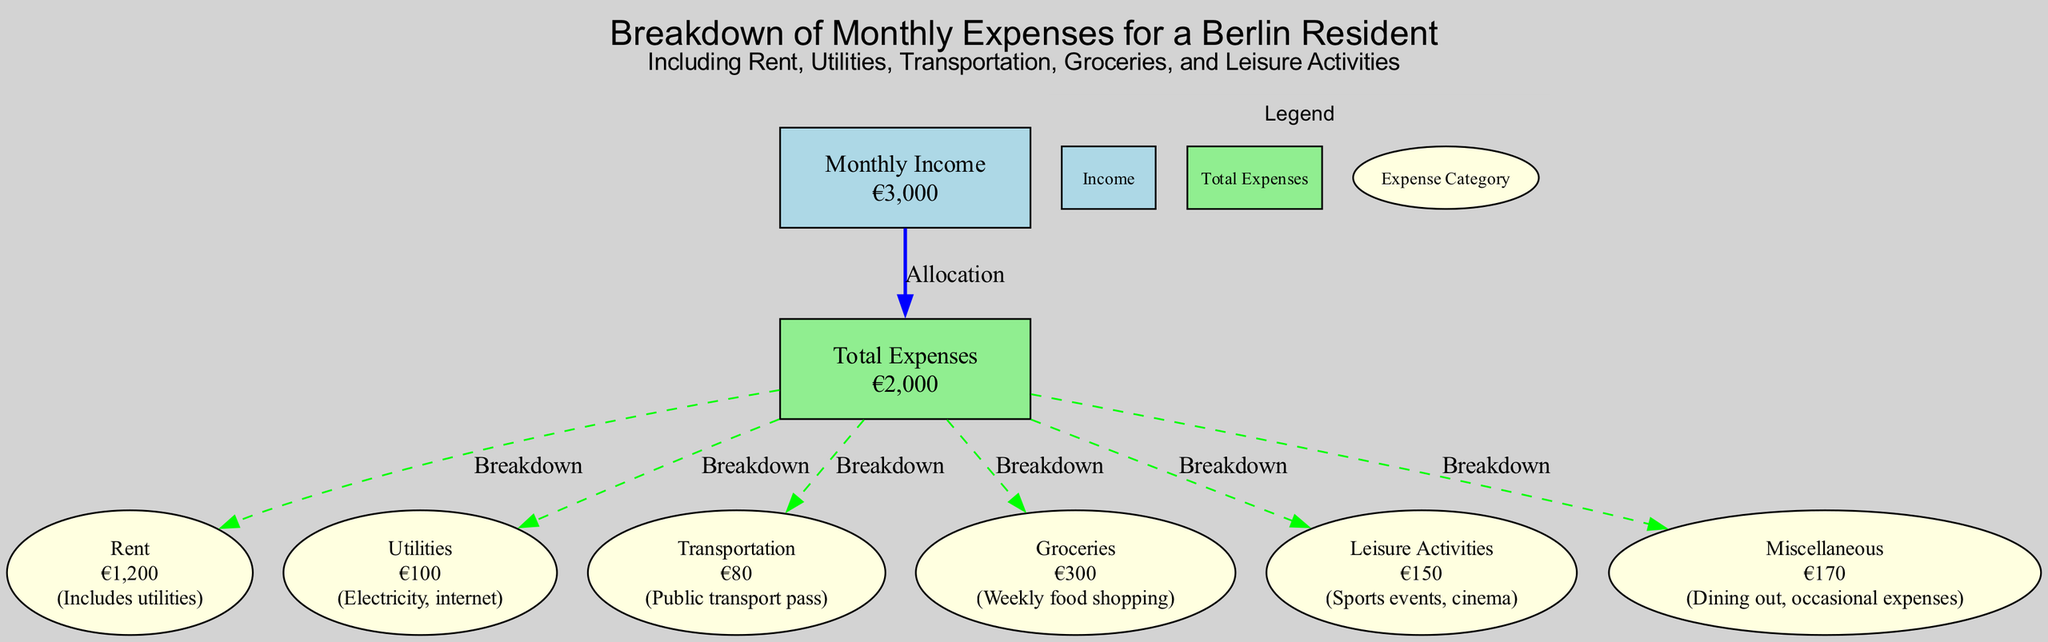What is the monthly income for a Berlin resident? The diagram clearly states that the monthly income is depicted in the node labeled "Monthly Income" with an amount of €3,000.
Answer: €3,000 What are the total expenses listed in the diagram? The "Total Expenses" node shows the amount of €2,000, which is the sum of all monthly expenses shown in the diagram.
Answer: €2,000 How much is spent on groceries? The node labeled "Groceries" lists the amount of €300, directly indicating the expense for groceries.
Answer: €300 Which expense category has the highest value? By comparing all expense amounts in the breakdown, "Rent" has the highest value at €1,200, making it the largest expense category.
Answer: Rent What is the combined total for utilities and transportation? The amount spent on "Utilities" is €100 and "Transportation" is €80. Adding these two amounts (100 + 80) results in €180, which represents the combined total.
Answer: €180 How much of the monthly income is allocated to leisure activities? The "Leisure Activities" node indicates an expense amount of €150, which shows the allocation for leisure activities directly.
Answer: €150 What percentage of the monthly income is represented by total expenses? To find the percentage, use the formula (total expenses / monthly income) * 100. Substituting the values gives (€2,000 / €3,000) * 100 = 66.67%. Thus, total expenses represent 66.67% of the monthly income.
Answer: 66.67% How many different expense categories are shown in the diagram? The diagram includes six distinct expense categories: Rent, Utilities, Transportation, Groceries, Leisure Activities, and Miscellaneous, totaling six categories.
Answer: 6 What descriptions are provided for various utilities? The "Utilities" node specifies that it includes electricity and internet; hence the description offers two details about the types of utilities covered in the expense.
Answer: Electricity, internet 